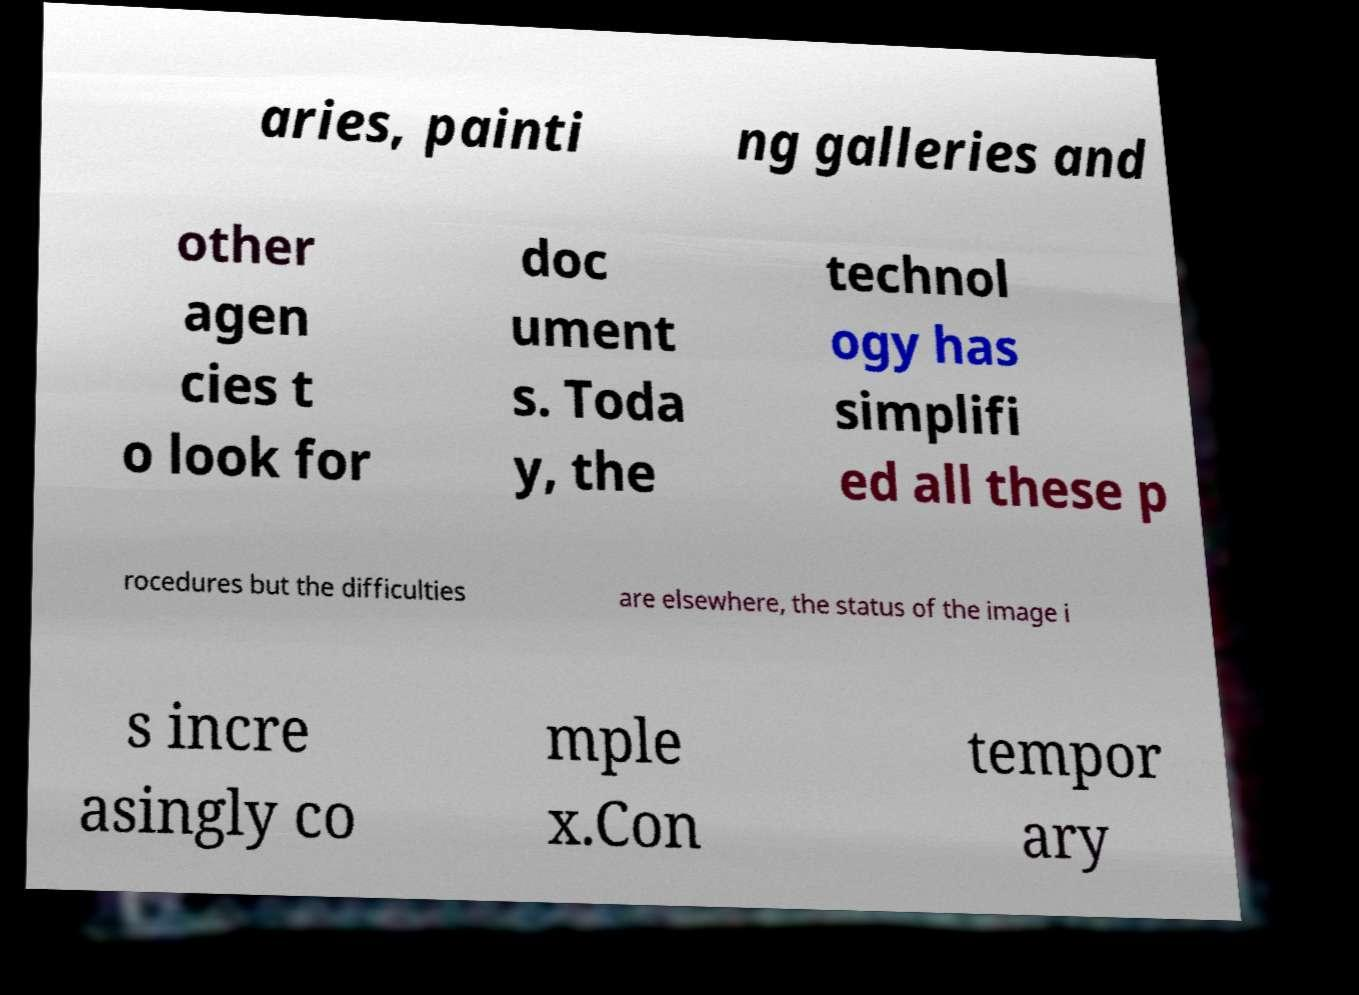Can you read and provide the text displayed in the image?This photo seems to have some interesting text. Can you extract and type it out for me? aries, painti ng galleries and other agen cies t o look for doc ument s. Toda y, the technol ogy has simplifi ed all these p rocedures but the difficulties are elsewhere, the status of the image i s incre asingly co mple x.Con tempor ary 